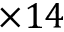<formula> <loc_0><loc_0><loc_500><loc_500>1 4</formula> 